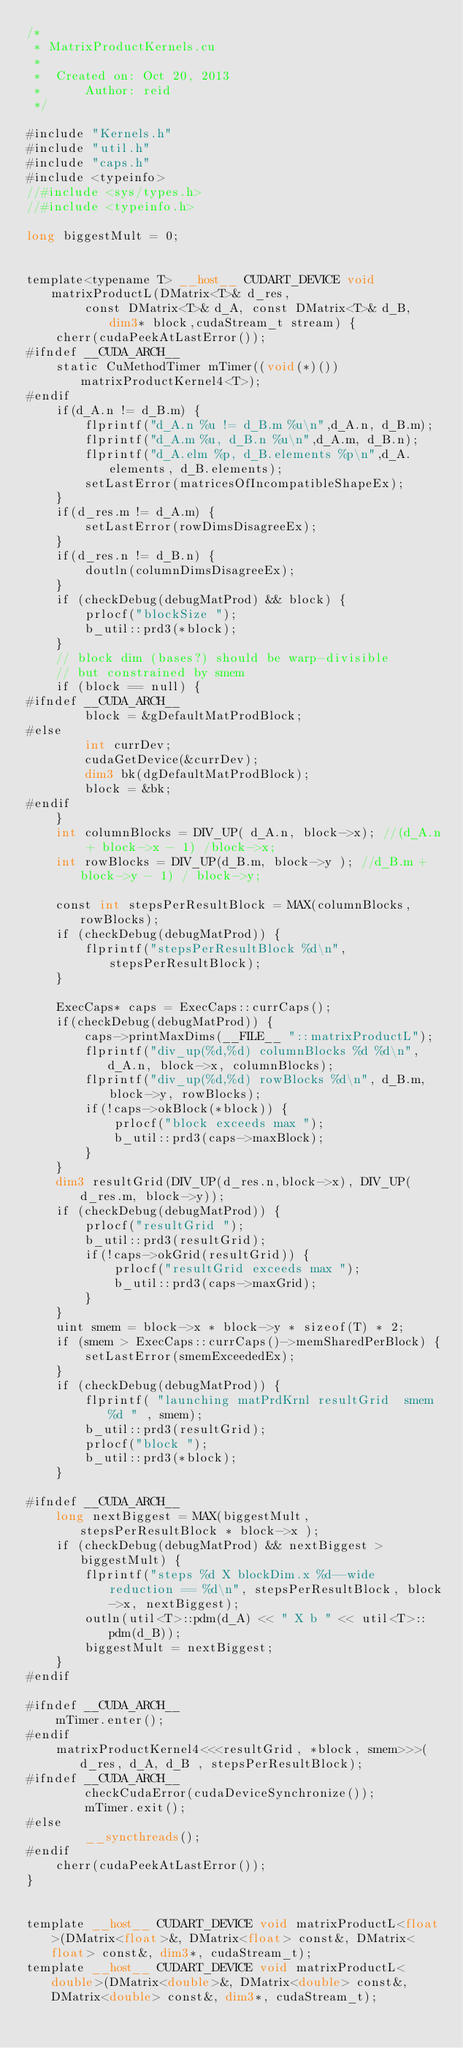Convert code to text. <code><loc_0><loc_0><loc_500><loc_500><_Cuda_>/*
 * MatrixProductKernels.cu
 *
 *  Created on: Oct 20, 2013
 *      Author: reid
 */

#include "Kernels.h"
#include "util.h"
#include "caps.h"
#include <typeinfo>
//#include <sys/types.h>
//#include <typeinfo.h>

long biggestMult = 0;


template<typename T> __host__ CUDART_DEVICE void matrixProductL(DMatrix<T>& d_res,
		const DMatrix<T>& d_A, const DMatrix<T>& d_B, dim3* block,cudaStream_t stream) {
	cherr(cudaPeekAtLastError());
#ifndef __CUDA_ARCH__
	static CuMethodTimer mTimer((void(*)())matrixProductKernel4<T>);
#endif
	if(d_A.n != d_B.m) {
		flprintf("d_A.n %u != d_B.m %u\n",d_A.n, d_B.m);
		flprintf("d_A.m %u, d_B.n %u\n",d_A.m, d_B.n);
		flprintf("d_A.elm %p, d_B.elements %p\n",d_A.elements, d_B.elements);
		setLastError(matricesOfIncompatibleShapeEx);
	}
	if(d_res.m != d_A.m) {
		setLastError(rowDimsDisagreeEx);
	}
	if(d_res.n != d_B.n) {
		doutln(columnDimsDisagreeEx);
	}
	if (checkDebug(debugMatProd) && block) {
		prlocf("blockSize ");
		b_util::prd3(*block);
	}
	// block dim (bases?) should be warp-divisible
	// but constrained by smem
	if (block == null) {
#ifndef __CUDA_ARCH__
		block = &gDefaultMatProdBlock;
#else
		int currDev;
		cudaGetDevice(&currDev);
		dim3 bk(dgDefaultMatProdBlock);
		block = &bk;
#endif
	}
	int columnBlocks = DIV_UP( d_A.n, block->x); //(d_A.n + block->x - 1) /block->x;
	int rowBlocks = DIV_UP(d_B.m, block->y ); //d_B.m + block->y - 1) / block->y;

	const int stepsPerResultBlock = MAX(columnBlocks,rowBlocks);
	if (checkDebug(debugMatProd)) {
		flprintf("stepsPerResultBlock %d\n", stepsPerResultBlock);
	}

	ExecCaps* caps = ExecCaps::currCaps();
	if(checkDebug(debugMatProd)) {
		caps->printMaxDims(__FILE__ "::matrixProductL");
		flprintf("div_up(%d,%d) columnBlocks %d %d\n",  d_A.n, block->x, columnBlocks);
		flprintf("div_up(%d,%d) rowBlocks %d\n", d_B.m, block->y, rowBlocks);
		if(!caps->okBlock(*block)) {
			prlocf("block exceeds max ");
			b_util::prd3(caps->maxBlock);
		}
	}
	dim3 resultGrid(DIV_UP(d_res.n,block->x), DIV_UP(d_res.m, block->y));
	if (checkDebug(debugMatProd)) {
		prlocf("resultGrid ");
		b_util::prd3(resultGrid);
		if(!caps->okGrid(resultGrid)) {
			prlocf("resultGrid exceeds max ");
			b_util::prd3(caps->maxGrid);
		}
	}
	uint smem = block->x * block->y * sizeof(T) * 2;
	if (smem > ExecCaps::currCaps()->memSharedPerBlock) {
		setLastError(smemExceededEx);
	}
	if (checkDebug(debugMatProd)) {
		flprintf( "launching matPrdKrnl resultGrid  smem %d " , smem);
		b_util::prd3(resultGrid);
		prlocf("block ");
		b_util::prd3(*block);
	}

#ifndef __CUDA_ARCH__
	long nextBiggest = MAX(biggestMult,stepsPerResultBlock * block->x );
	if (checkDebug(debugMatProd) && nextBiggest > biggestMult) {
		flprintf("steps %d X blockDim.x %d--wide reduction == %d\n", stepsPerResultBlock, block->x, nextBiggest);
		outln(util<T>::pdm(d_A) << " X b " << util<T>::pdm(d_B));
		biggestMult = nextBiggest;
	}
#endif

#ifndef __CUDA_ARCH__
	mTimer.enter();
#endif
	matrixProductKernel4<<<resultGrid, *block, smem>>>(d_res, d_A, d_B , stepsPerResultBlock);
#ifndef __CUDA_ARCH__
		checkCudaError(cudaDeviceSynchronize());
		mTimer.exit();
#else
		__syncthreads();
#endif
	cherr(cudaPeekAtLastError());
}


template __host__ CUDART_DEVICE void matrixProductL<float>(DMatrix<float>&, DMatrix<float> const&, DMatrix<float> const&, dim3*, cudaStream_t);
template __host__ CUDART_DEVICE void matrixProductL<double>(DMatrix<double>&, DMatrix<double> const&, DMatrix<double> const&, dim3*, cudaStream_t);</code> 